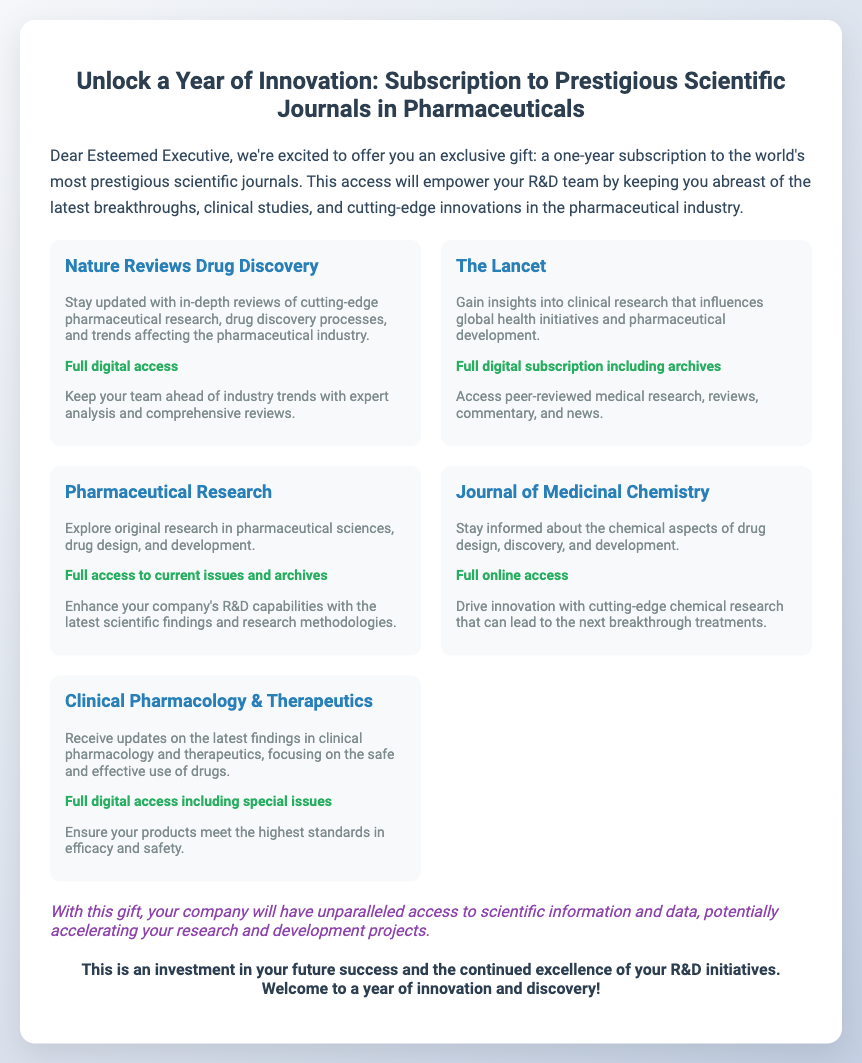what is the title of the voucher? The title is prominently displayed in the header section of the voucher document.
Answer: Unlock a Year of Innovation: Subscription to Prestigious Scientific Journals in Pharmaceuticals how long is the subscription offered? The introductory paragraph specifies the duration of the subscription clearly.
Answer: One year which journal focuses on drug discovery processes? The document lists each journal along with their specific focus areas.
Answer: Nature Reviews Drug Discovery what access is provided for The Lancet? The access type for this journal is specified in the detailed description.
Answer: Full digital subscription including archives how many journals are featured in the document? The total count of journals can be seen listed in the journal section of the document.
Answer: Five what is one benefit of the subscription mentioned in the document? The value section outlines key advantages of having the subscription.
Answer: Unparalleled access to scientific information which area of research does Pharmaceutical Research cover? The document gives a brief overview of the focus of each journal in its description.
Answer: Pharmaceutical sciences, drug design, and development what is emphasized as an investment? The closing paragraph highlights the nature of the subscription in the context of company success.
Answer: Investment in your future success which journal focuses on clinical pharmacology and therapeutics? The documents list the journals along with their specific emphasis.
Answer: Clinical Pharmacology & Therapeutics 